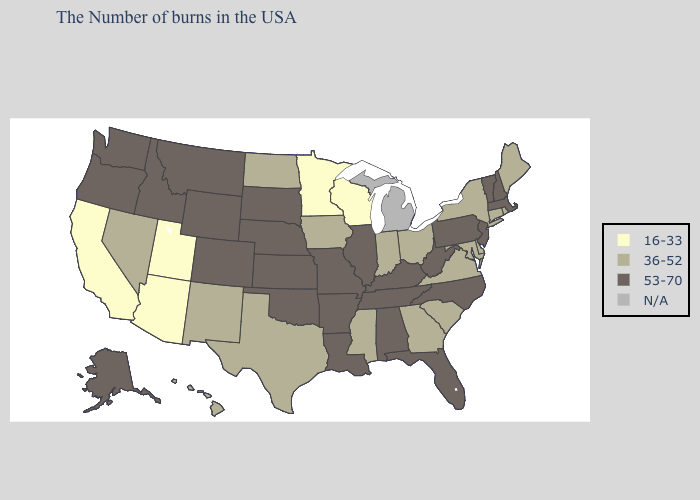Does North Carolina have the lowest value in the South?
Keep it brief. No. What is the value of Colorado?
Be succinct. 53-70. Name the states that have a value in the range N/A?
Answer briefly. Michigan. Name the states that have a value in the range 16-33?
Give a very brief answer. Wisconsin, Minnesota, Utah, Arizona, California. What is the highest value in states that border Texas?
Keep it brief. 53-70. What is the lowest value in states that border Montana?
Write a very short answer. 36-52. Name the states that have a value in the range 53-70?
Quick response, please. Massachusetts, New Hampshire, Vermont, New Jersey, Pennsylvania, North Carolina, West Virginia, Florida, Kentucky, Alabama, Tennessee, Illinois, Louisiana, Missouri, Arkansas, Kansas, Nebraska, Oklahoma, South Dakota, Wyoming, Colorado, Montana, Idaho, Washington, Oregon, Alaska. Name the states that have a value in the range 53-70?
Short answer required. Massachusetts, New Hampshire, Vermont, New Jersey, Pennsylvania, North Carolina, West Virginia, Florida, Kentucky, Alabama, Tennessee, Illinois, Louisiana, Missouri, Arkansas, Kansas, Nebraska, Oklahoma, South Dakota, Wyoming, Colorado, Montana, Idaho, Washington, Oregon, Alaska. What is the value of Texas?
Write a very short answer. 36-52. Name the states that have a value in the range 36-52?
Give a very brief answer. Maine, Rhode Island, Connecticut, New York, Delaware, Maryland, Virginia, South Carolina, Ohio, Georgia, Indiana, Mississippi, Iowa, Texas, North Dakota, New Mexico, Nevada, Hawaii. Among the states that border South Carolina , does Georgia have the lowest value?
Be succinct. Yes. Does Wyoming have the highest value in the West?
Be succinct. Yes. 